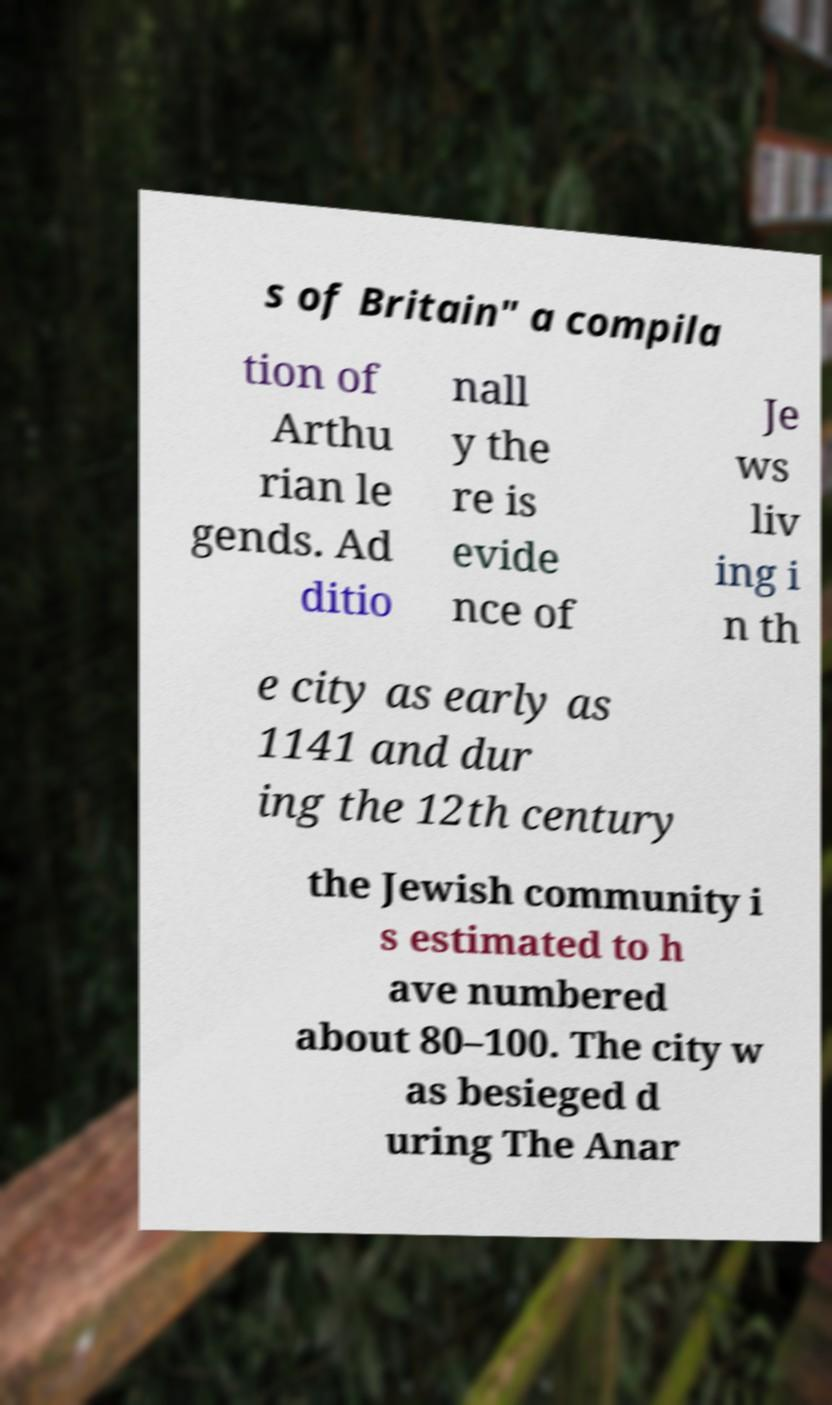Can you accurately transcribe the text from the provided image for me? s of Britain" a compila tion of Arthu rian le gends. Ad ditio nall y the re is evide nce of Je ws liv ing i n th e city as early as 1141 and dur ing the 12th century the Jewish community i s estimated to h ave numbered about 80–100. The city w as besieged d uring The Anar 